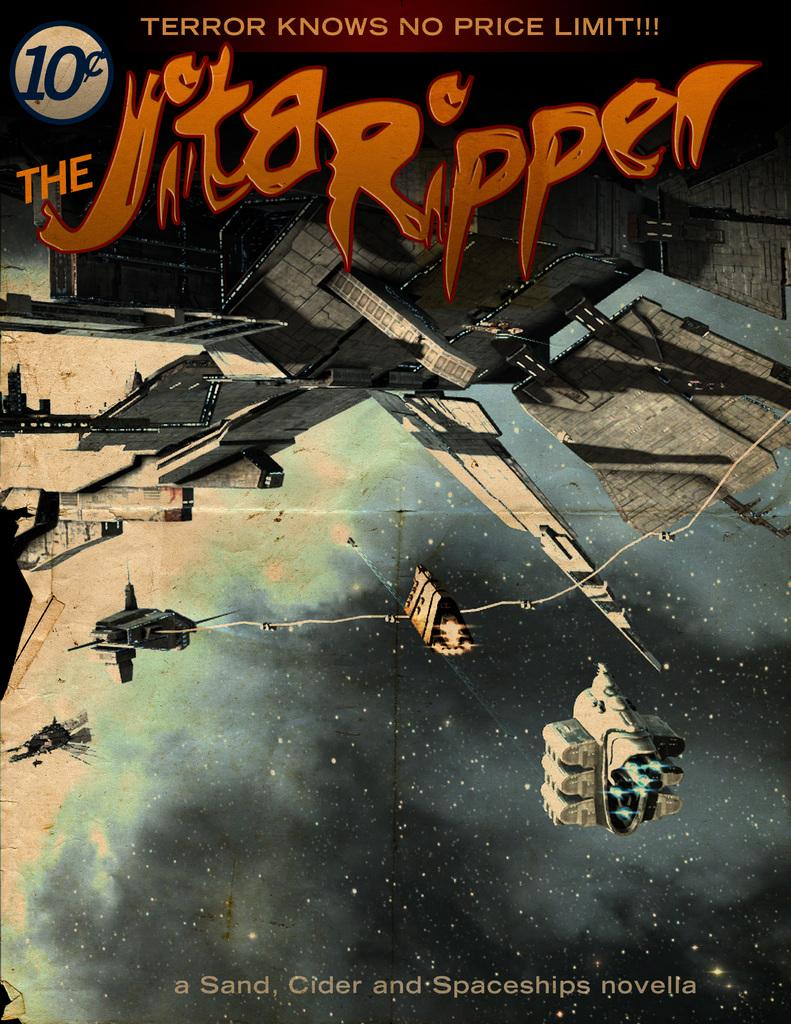What is featured on the poster in the image? The poster contains an image of a building and a skyrocket. What else can be found on the poster besides the images? There is text written on the poster. What type of sign is hanging from the wire in the image? There is no sign or wire present in the image; it only features a poster with images and text. 